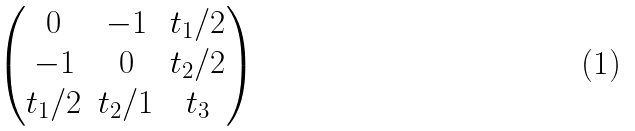Convert formula to latex. <formula><loc_0><loc_0><loc_500><loc_500>\begin{pmatrix} 0 & - 1 & t _ { 1 } / 2 \\ - 1 & 0 & t _ { 2 } / 2 \\ t _ { 1 } / 2 & t _ { 2 } / 1 & t _ { 3 } \end{pmatrix}</formula> 